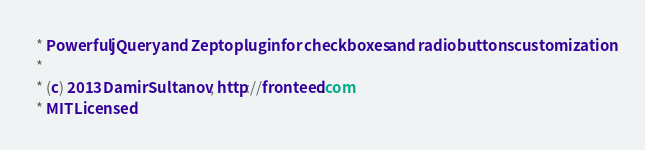Convert code to text. <code><loc_0><loc_0><loc_500><loc_500><_CSS_> * Powerful jQuery and Zepto plugin for checkboxes and radio buttons customization
 *
 * (c) 2013 Damir Sultanov, http://fronteed.com
 * MIT Licensed</code> 